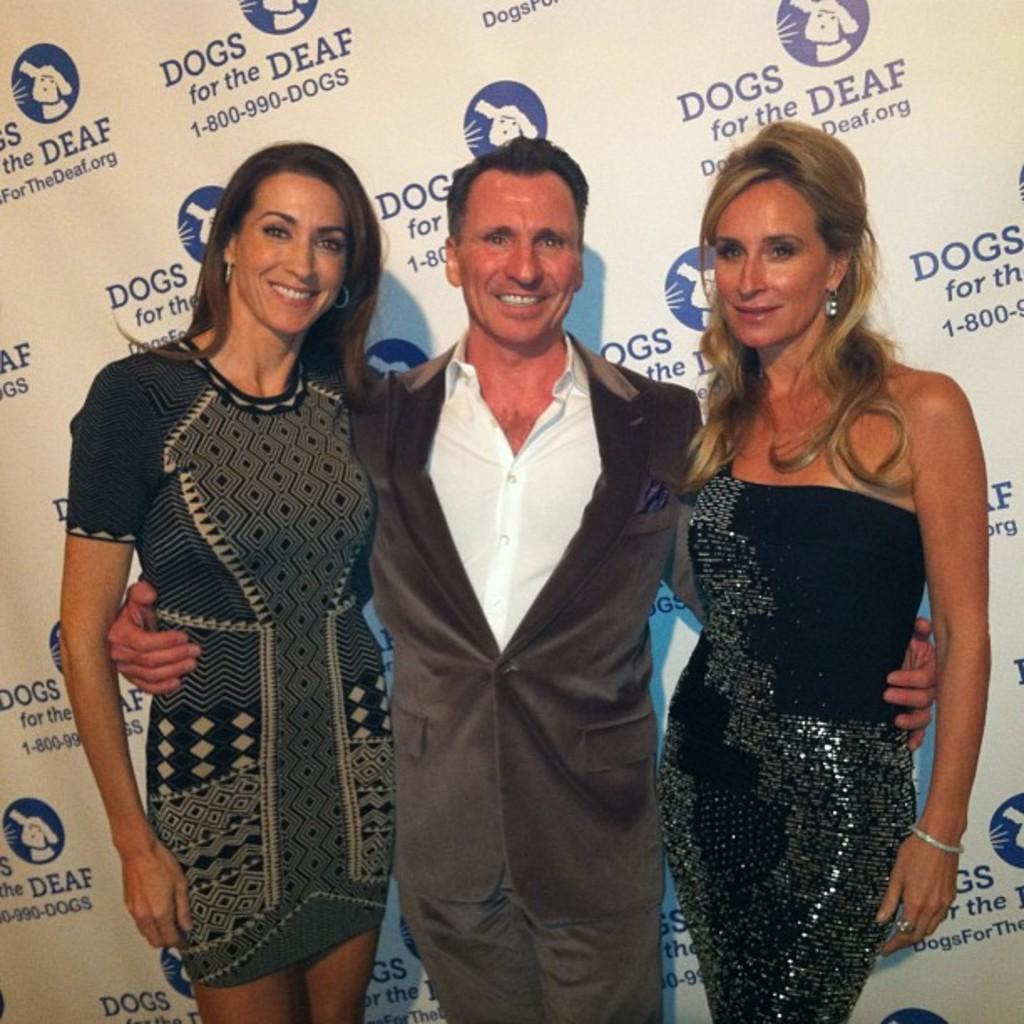How many people are in the image? There are two women and a man in the image, making a total of three people. What are the people in the image doing? The people are standing in the image. What can be seen in the background of the image? There is a hoarding visible in the background. What expressions do the people have in the image? The people in the image are smiling. What type of street is visible in the image? There is no street visible in the image; it only shows three people standing and a hoarding in the background. 